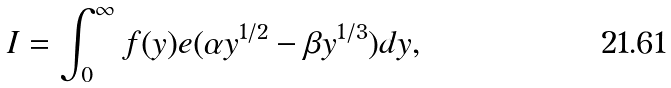<formula> <loc_0><loc_0><loc_500><loc_500>I = \int _ { 0 } ^ { \infty } f ( y ) e ( \alpha y ^ { 1 / 2 } - \beta y ^ { 1 / 3 } ) d y ,</formula> 